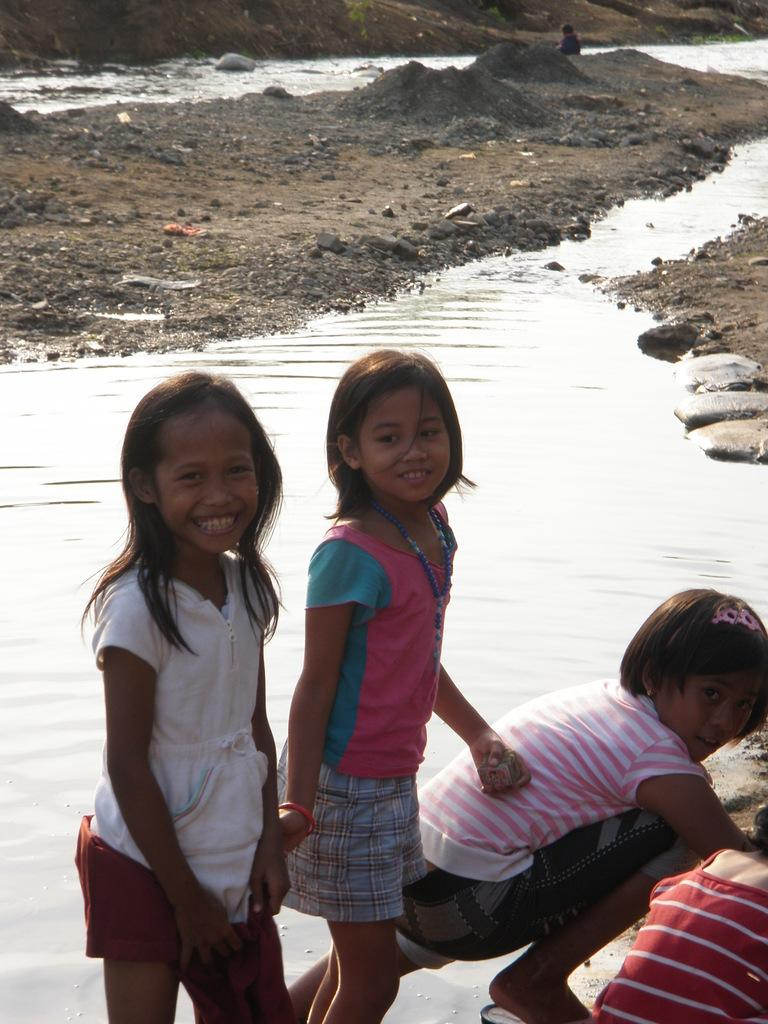What can be seen in the image? There are kids in the image. How are the kids positioned and what are they doing? The kids are standing and smiling. What is the setting of the image? There is water visible in the image, and there are stones present. Can you describe the person in the background of the image? There is a person in the background of the image, but no specific details about them are provided. What type of bird is flying over the kids in the image? There is no bird visible in the image; it only features kids, water, stones, and a person in the background. 